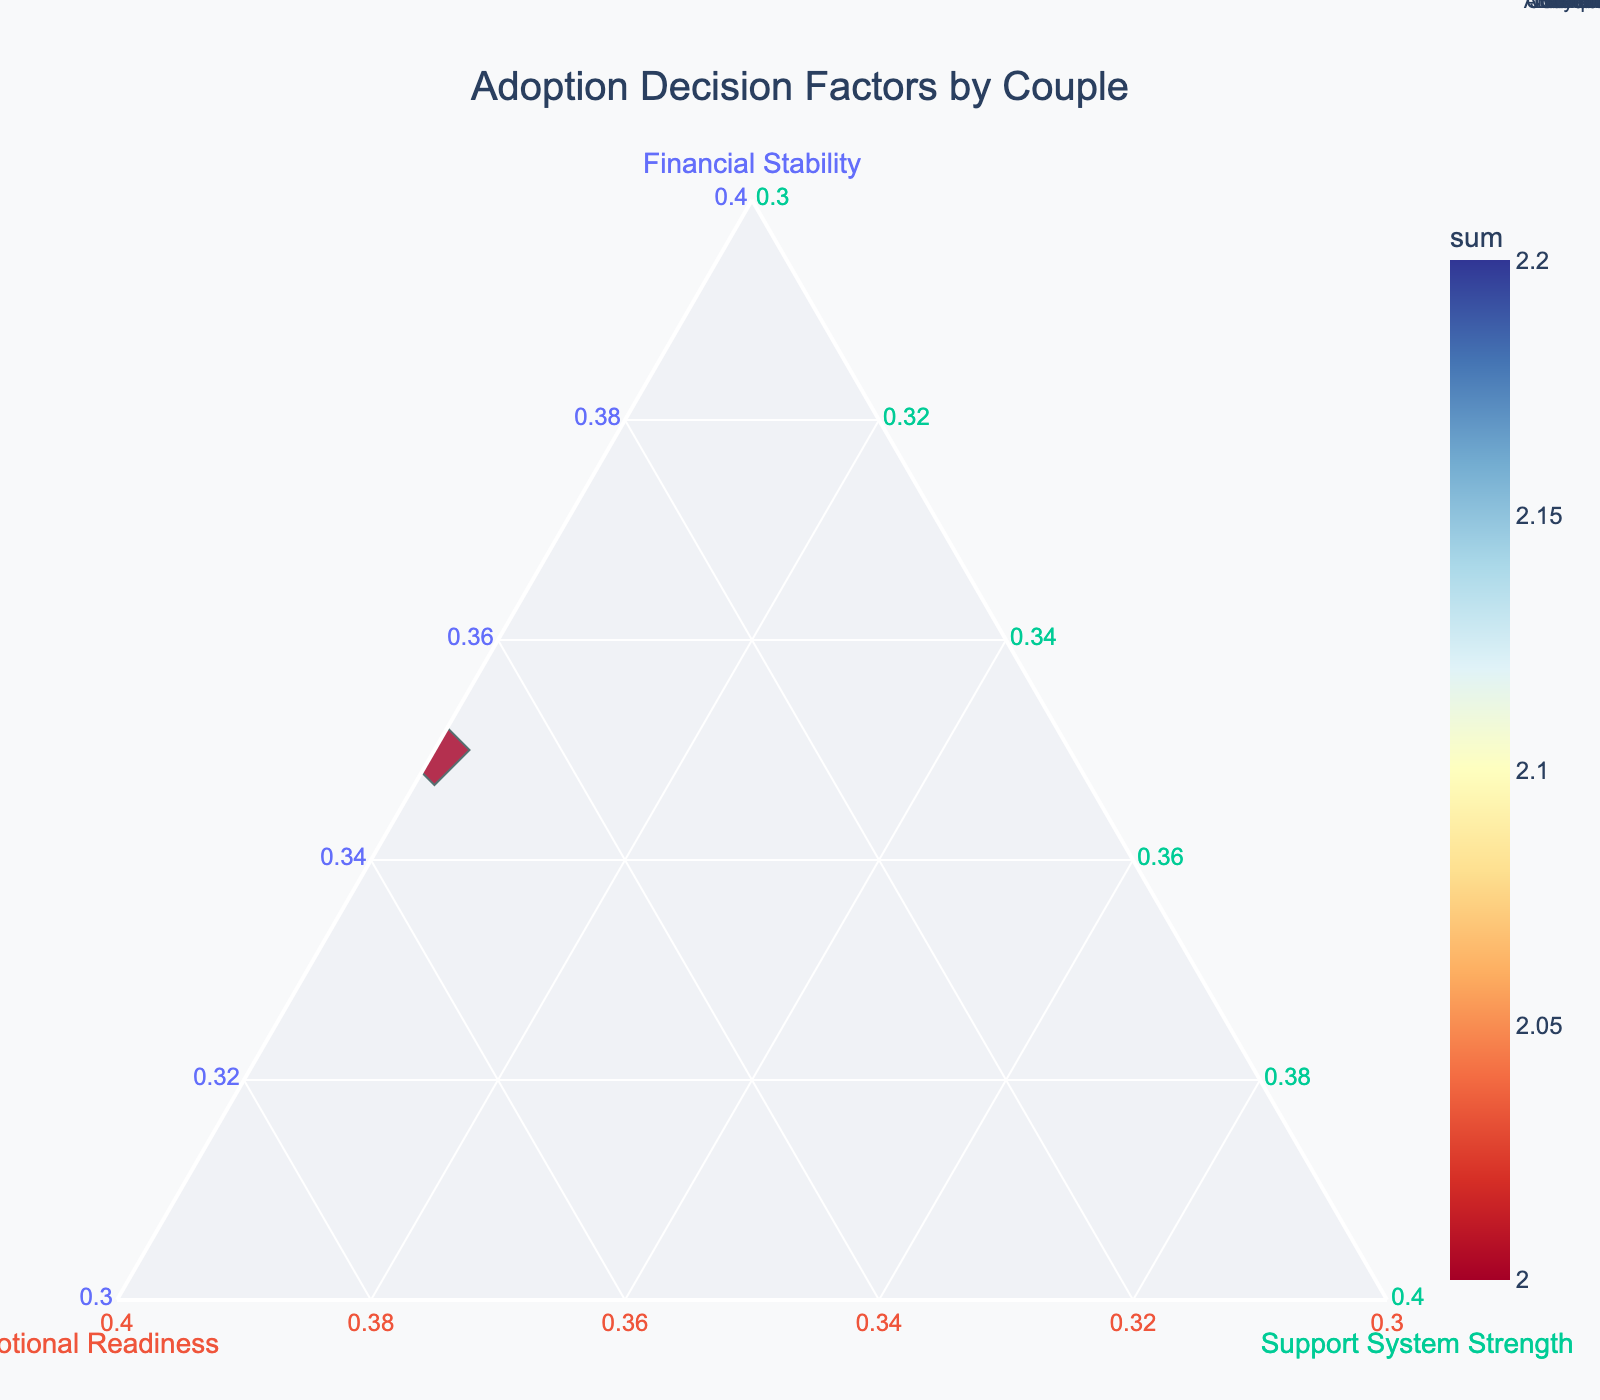How many couples are represented in the ternary plot? There are 10 couples listed in the data provided: Johnson Family, Smith Couple, Garcia-Lopez, Williams Pair, Chen Household, Brown Duo, Taylor Family, Anderson Couple, Murphy Pair, and Lee Household.
Answer: 10 Which couple has the highest financial stability? By looking at the normalized financial stability values, the Williams Pair and Murphy Pair both have the highest financial stability with a score of 0.9.
Answer: Williams Pair, Murphy Pair Which couple appears to have the most balanced contributions in terms of financial stability, emotional readiness, and support system strength? A couple with the most balanced contributions would have approximately equal values for all three factors. Brown Duo has values of 0.7 for financial stability, 0.7 for emotional readiness, and 0.6 for support system strength, making them quite balanced.
Answer: Brown Duo Is there a couple that has consistently high scores across all factors? A consistently high score in all factors means that all values (financial stability, emotional readiness, and support system strength) are high. The Johnson Family scores 0.6, 0.7, and 0.8 respectively, and Garcia-Lopez scores 0.7, 0.8, and 0.6, indicating consistency in high scores.
Answer: Johnson Family, Garcia-Lopez Which couple has the lowest score for emotional readiness? The Smith Couple has the lowest score for emotional readiness with a value of 0.5.
Answer: Smith Couple Compare the support system strength between the Anderson Couple and the Williams Pair. Which one is stronger? By looking at the normalized support system strength values, the Anderson Couple has a higher support system strength score of 0.9 compared to the Williams Pair's score of 0.5.
Answer: Anderson Couple Rank the couples from the highest to the lowest in terms of their overall score sum. The overall score sum is the addition of financial stability, emotional readiness, and support system strength. The sums for each couple are: Anderson Couple (2.1), Johnson Family (2.1), Smith Couple (2.0), Garcia-Lopez (2.1), Williams Pair (2.0), Chen Household (2.1), Brown Duo (2.0), Taylor Family (2.1), Murphy Pair (2.2), and Lee Household (2.0).
Answer: Murphy Pair > Anderson Couple = Johnson Family = Garcia-Lopez = Chen Household = Taylor Family > Smith Couple = Williams Pair = Brown Duo = Lee Household Which couple is closest to achieving the perfect balance of all three factors? To determine a close balance, check the differences between values of financial stability, emotional readiness, and support system strength. Brown Duo has similar values for all factors: 0.7, 0.7, and 0.6, suggesting a good balance.
Answer: Brown Duo 